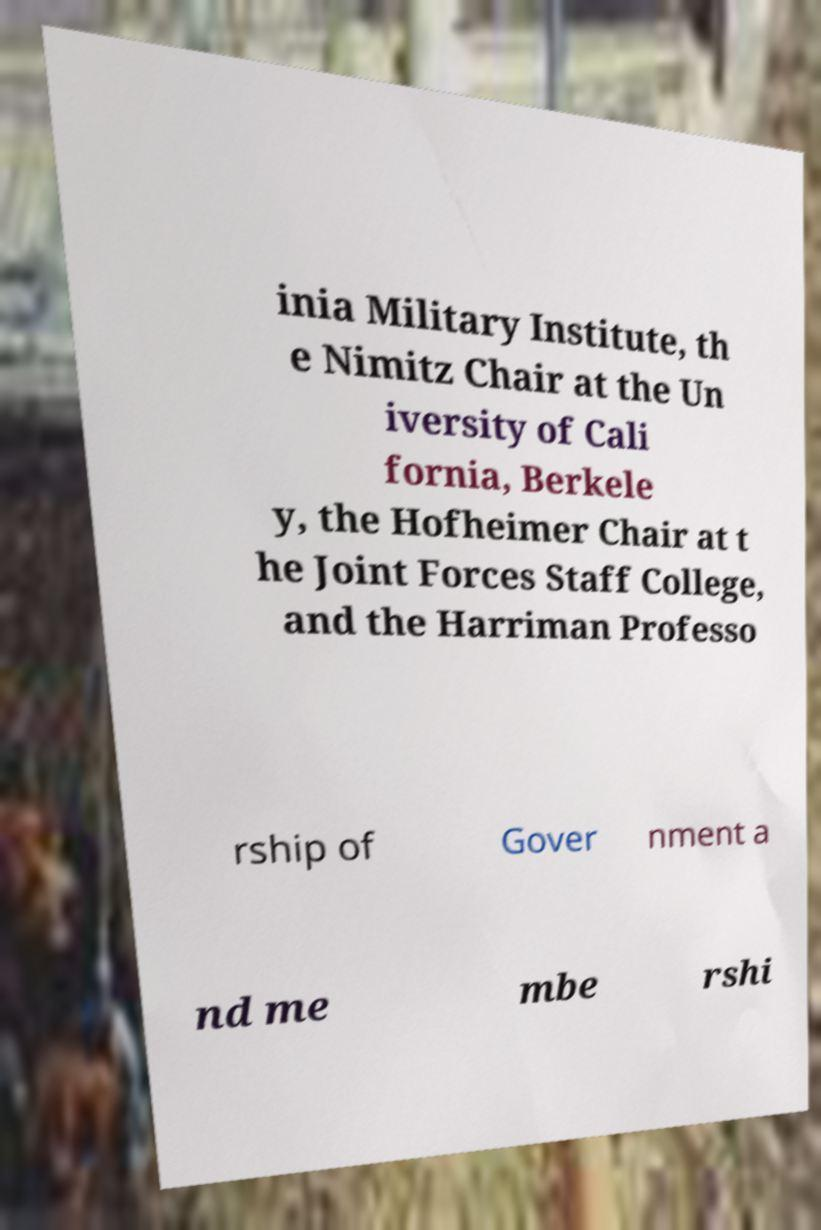Could you assist in decoding the text presented in this image and type it out clearly? inia Military Institute, th e Nimitz Chair at the Un iversity of Cali fornia, Berkele y, the Hofheimer Chair at t he Joint Forces Staff College, and the Harriman Professo rship of Gover nment a nd me mbe rshi 